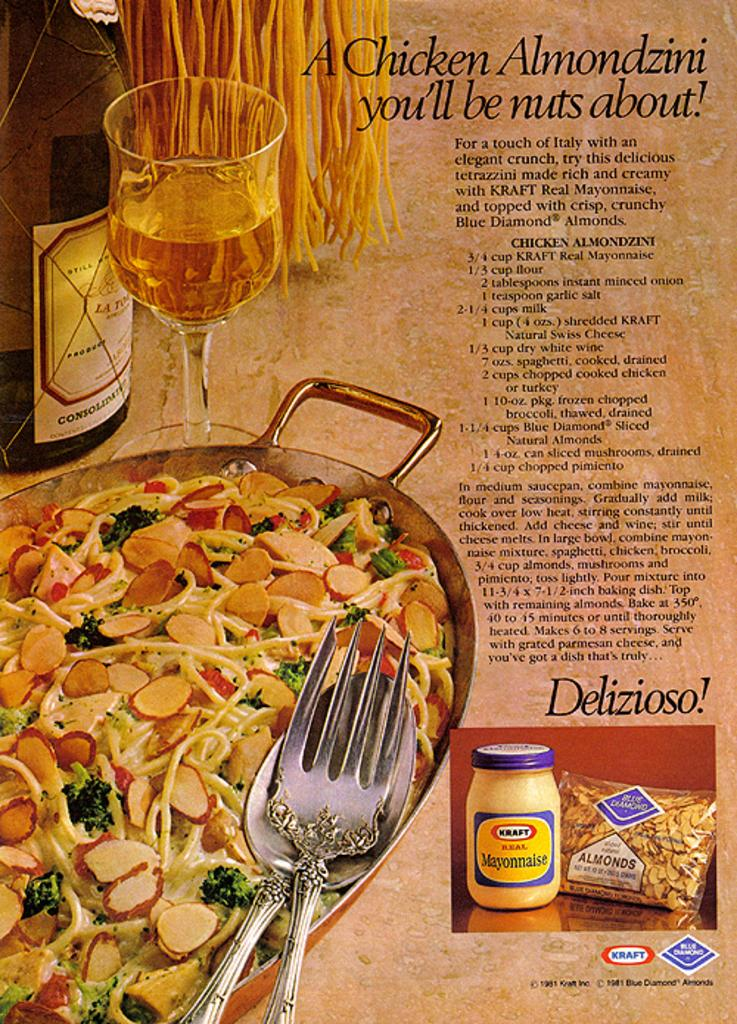What is the main subject of the poster in the image? The main subject of the poster in the image is a bottle. What other objects are depicted on the poster? The poster contains images of a glass, food items, and various objects. Is there any text present on the poster? Yes, the poster contains text. How many cows are visible on the poster? There are no cows depicted on the poster; it features images of a bottle, a glass, food items, and various objects. 